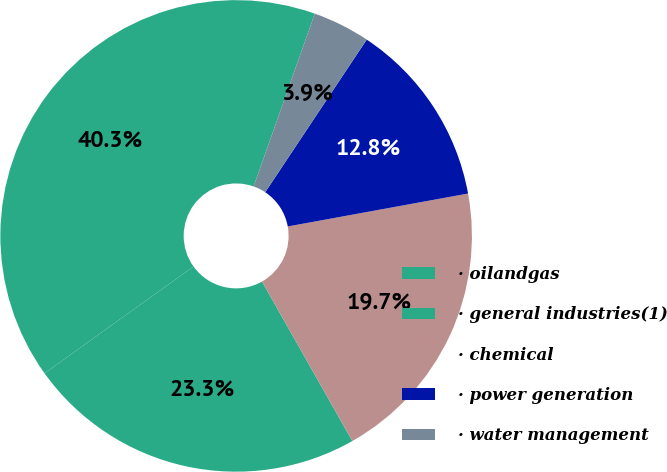Convert chart. <chart><loc_0><loc_0><loc_500><loc_500><pie_chart><fcel>· oilandgas<fcel>· general industries(1)<fcel>· chemical<fcel>· power generation<fcel>· water management<nl><fcel>40.31%<fcel>23.3%<fcel>19.67%<fcel>12.78%<fcel>3.93%<nl></chart> 